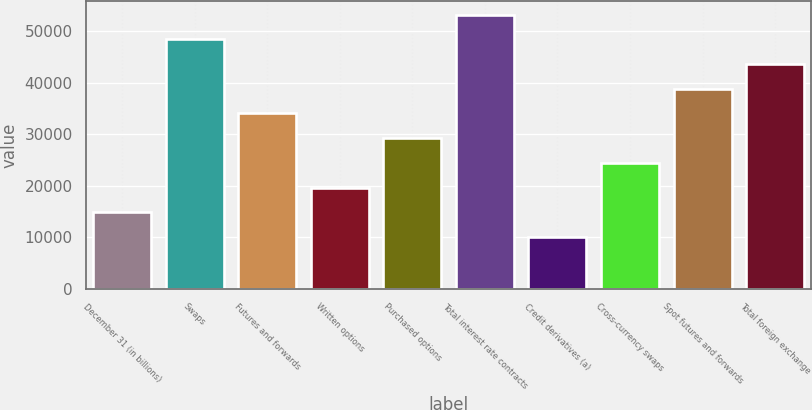<chart> <loc_0><loc_0><loc_500><loc_500><bar_chart><fcel>December 31 (in billions)<fcel>Swaps<fcel>Futures and forwards<fcel>Written options<fcel>Purchased options<fcel>Total interest rate contracts<fcel>Credit derivatives (a)<fcel>Cross-currency swaps<fcel>Spot futures and forwards<fcel>Total foreign exchange<nl><fcel>14848.3<fcel>48386<fcel>34012.7<fcel>19639.4<fcel>29221.6<fcel>53177.1<fcel>10057.2<fcel>24430.5<fcel>38803.8<fcel>43594.9<nl></chart> 